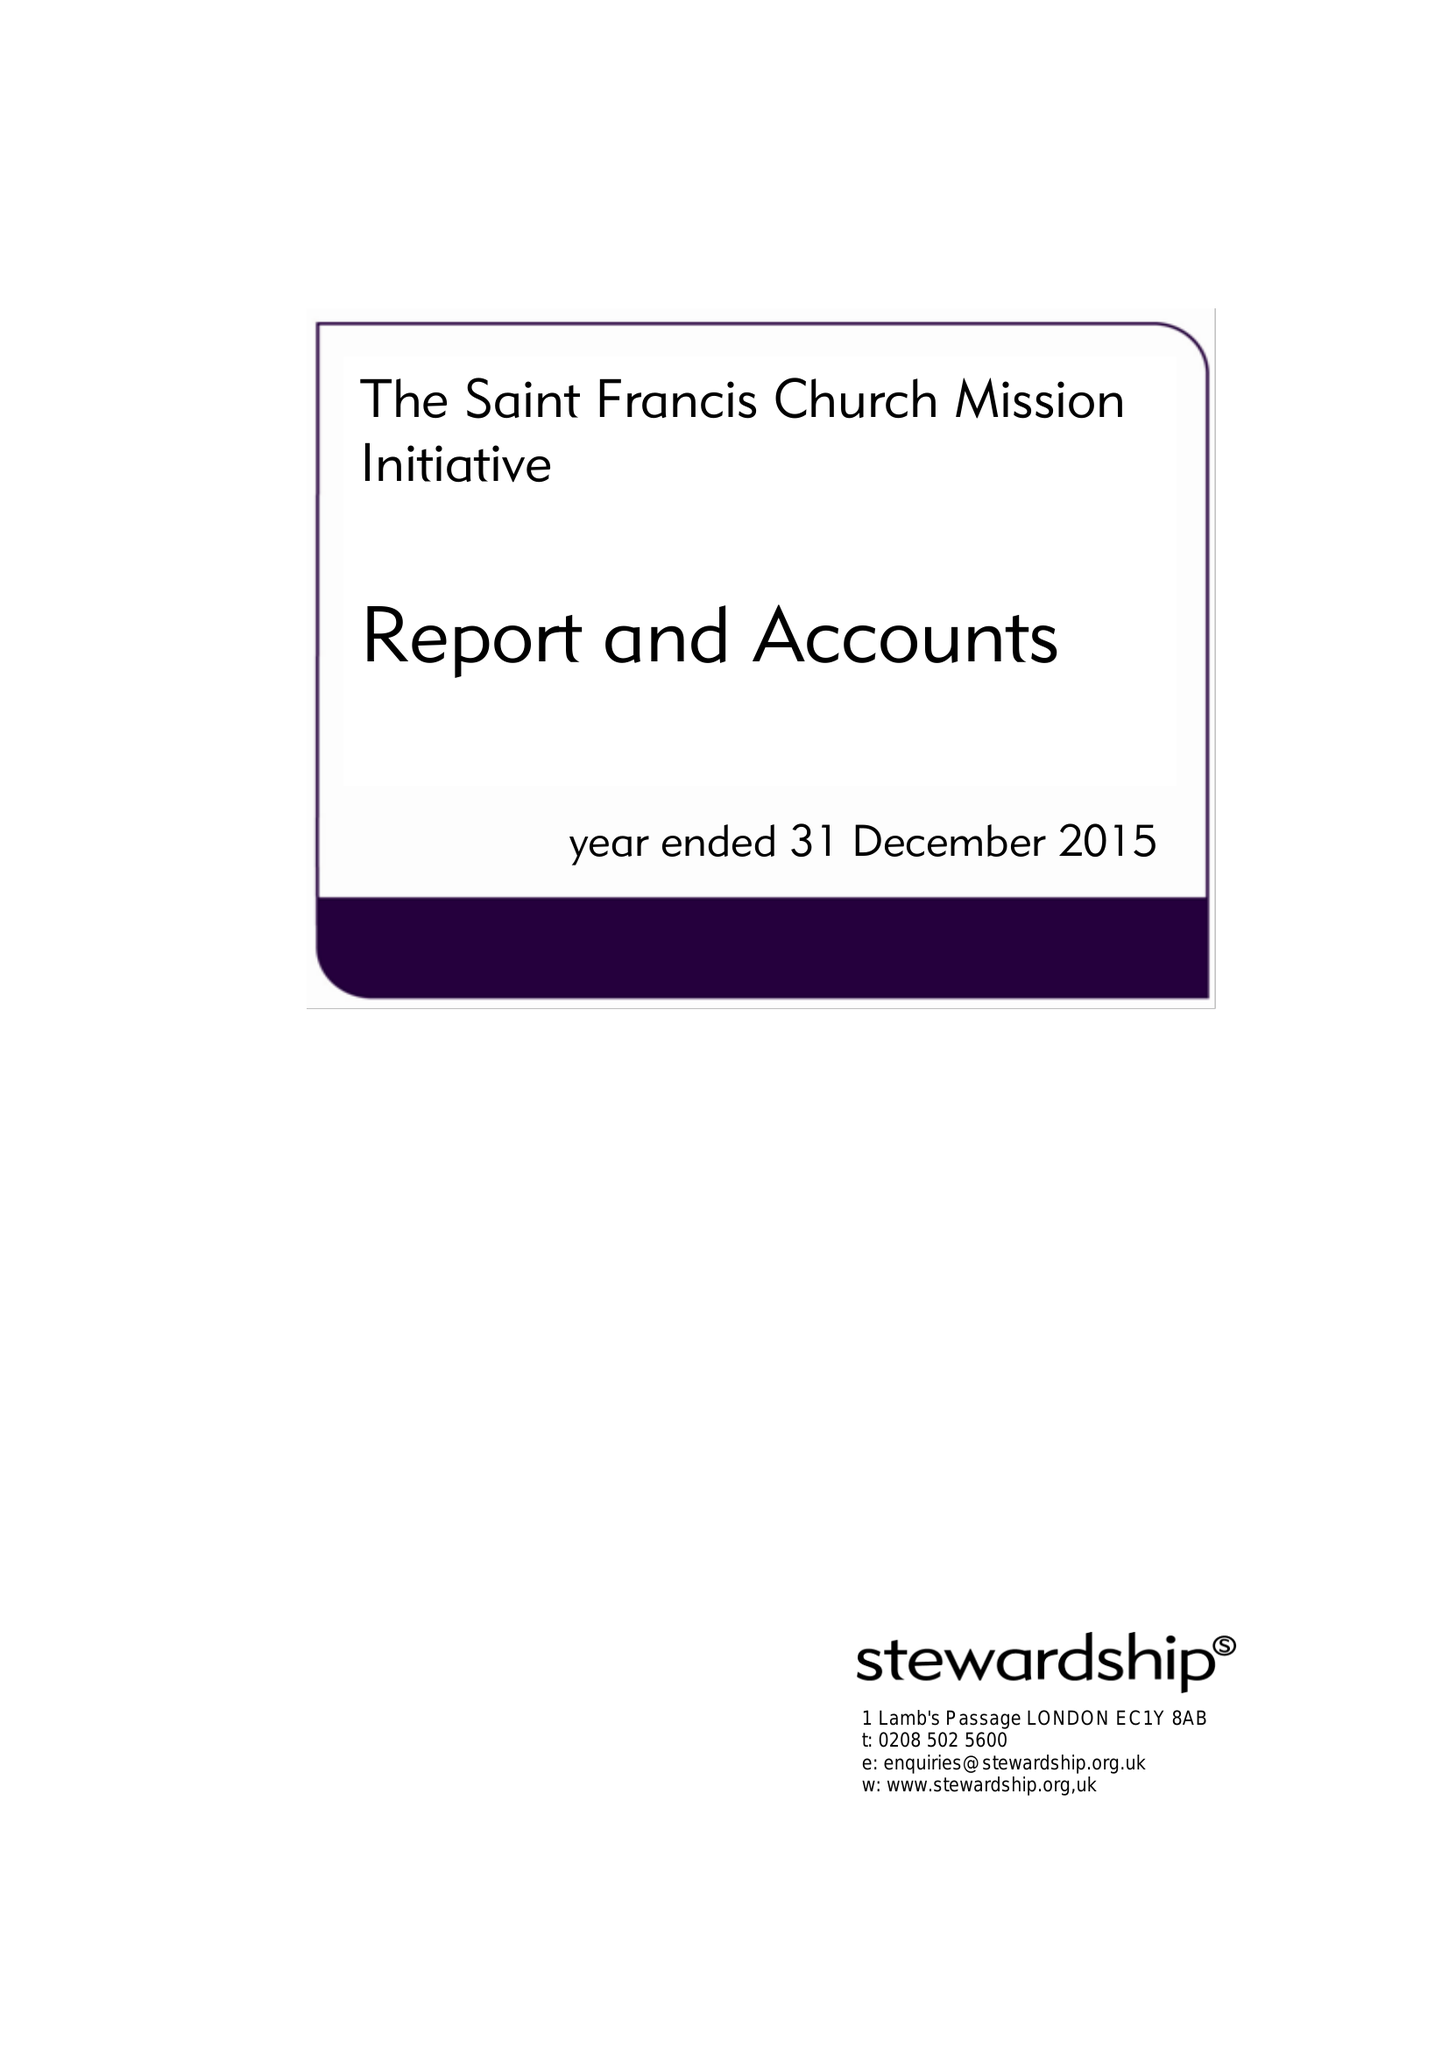What is the value for the address__post_town?
Answer the question using a single word or phrase. LONDON 